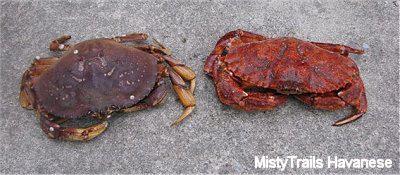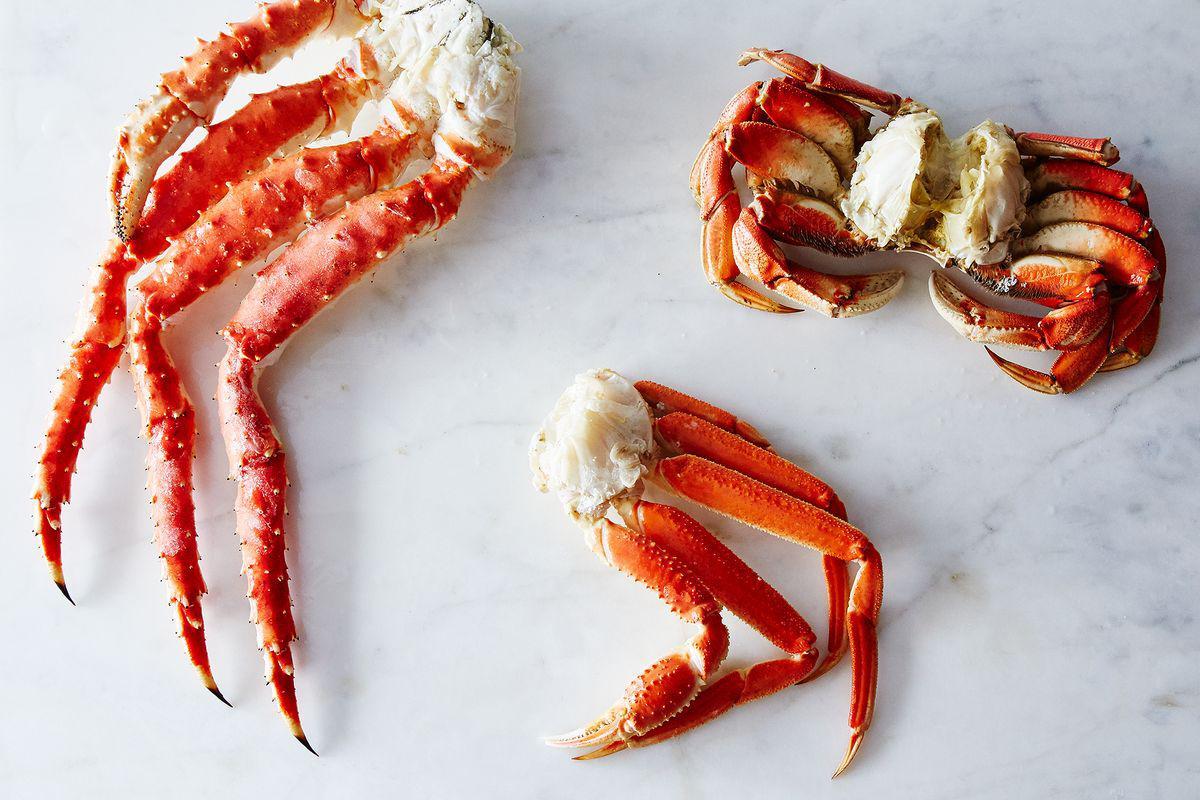The first image is the image on the left, the second image is the image on the right. Analyze the images presented: Is the assertion "All of the crabs in the images are still whole." valid? Answer yes or no. No. The first image is the image on the left, the second image is the image on the right. Assess this claim about the two images: "The left image contains two crabs.". Correct or not? Answer yes or no. Yes. 